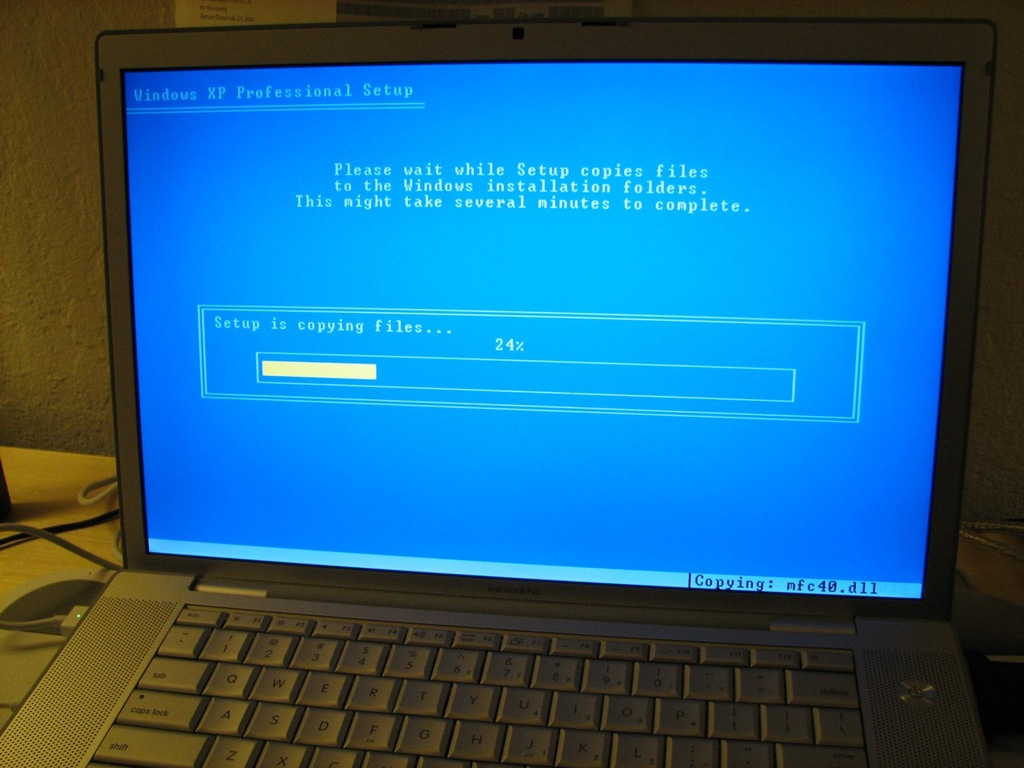Describe the following image. The image vividly captures the midpoint of a Windows XP Professional setup process on a computer screen. You can see the iconic blue background typical during the installation phase, with a progress bar indicating 24% completion. The monitor shows that the setup is currently copying a critical system file named 'netcfg.dll,' essential for network configurations. This setup screen is not just a technical detail; it represents a nostalgic throwback to the early 2000s, when Windows XP was a dominant force in computing, widely appreciated for its improved graphical user interface and enhanced stability compared to previous Windows versions. The slow progression of the installation bar, patiently awaited by many, sometimes turned into an unexpectedly lengthy ordeal due to common installation hiccups, making this image a relatable moment for anyone who has ever set up Windows. 